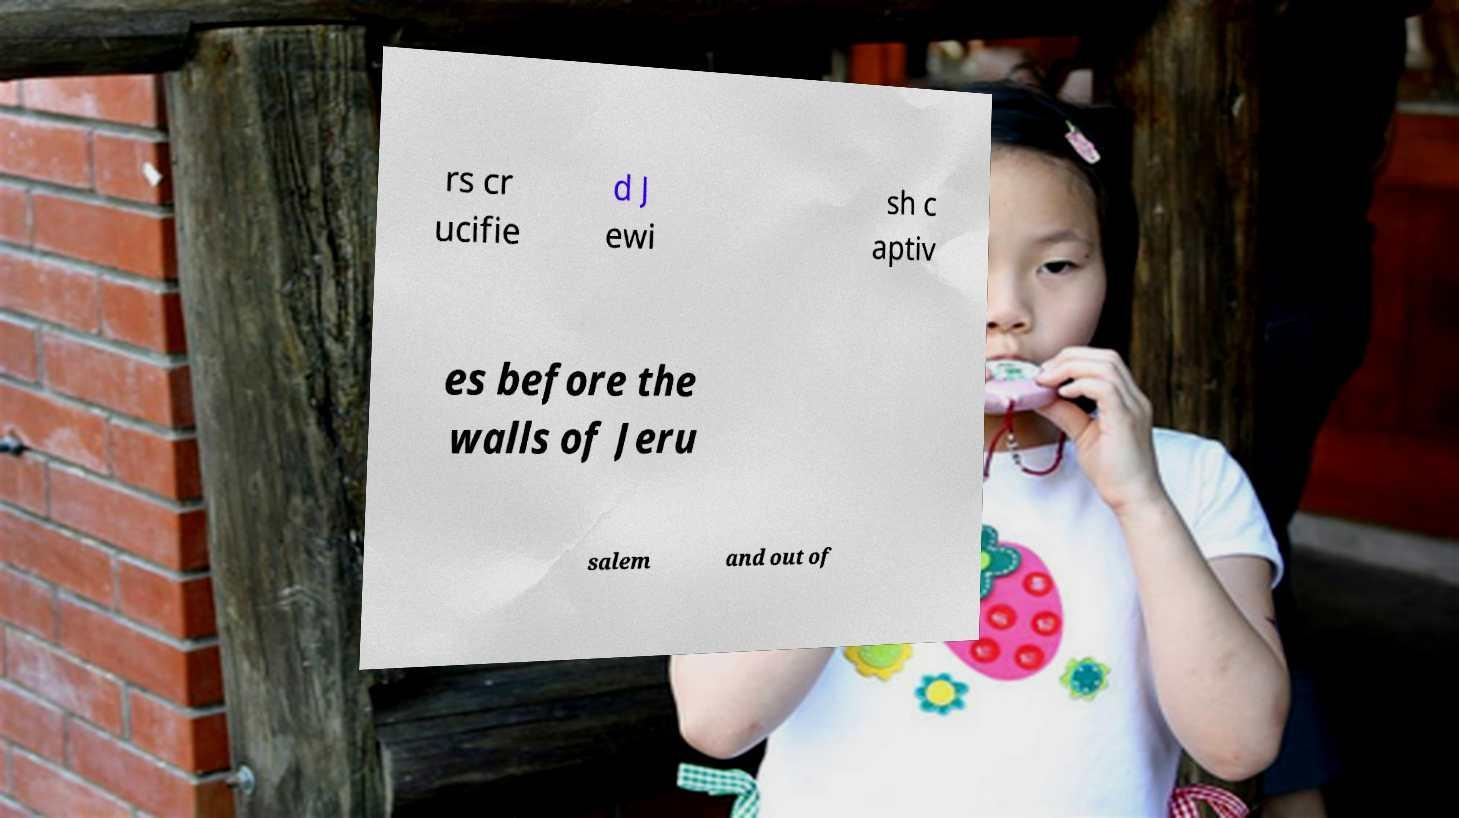For documentation purposes, I need the text within this image transcribed. Could you provide that? rs cr ucifie d J ewi sh c aptiv es before the walls of Jeru salem and out of 